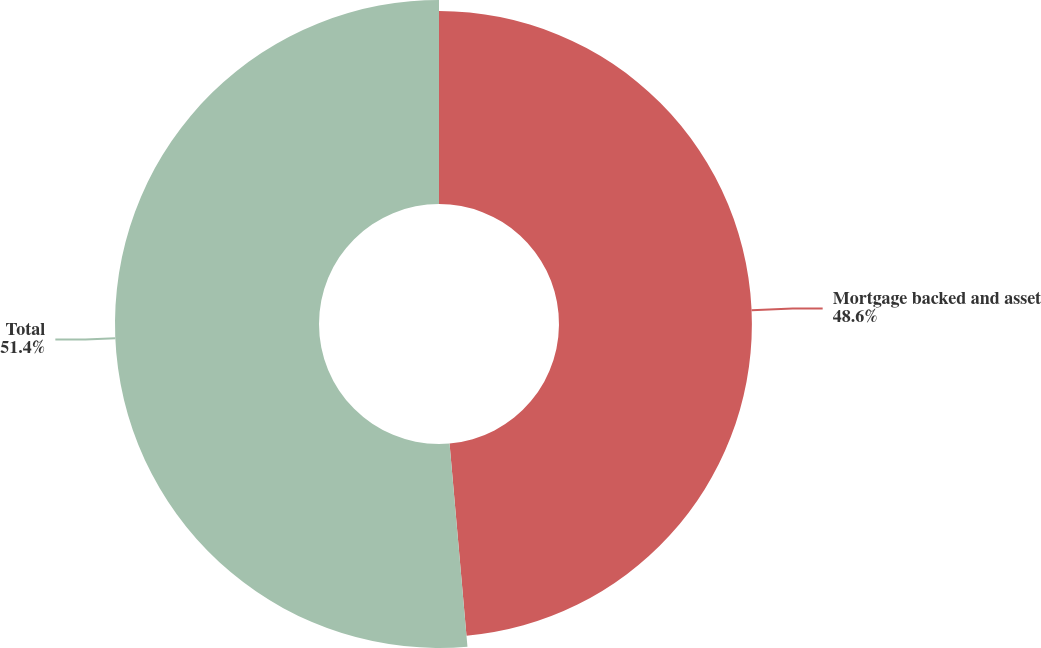<chart> <loc_0><loc_0><loc_500><loc_500><pie_chart><fcel>Mortgage backed and asset<fcel>Total<nl><fcel>48.6%<fcel>51.4%<nl></chart> 